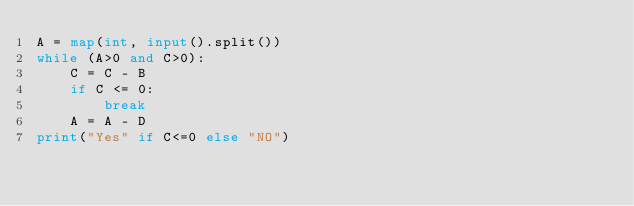<code> <loc_0><loc_0><loc_500><loc_500><_Python_>A = map(int, input().split())
while (A>0 and C>0):
    C = C - B
    if C <= 0:
        break
    A = A - D
print("Yes" if C<=0 else "NO")</code> 